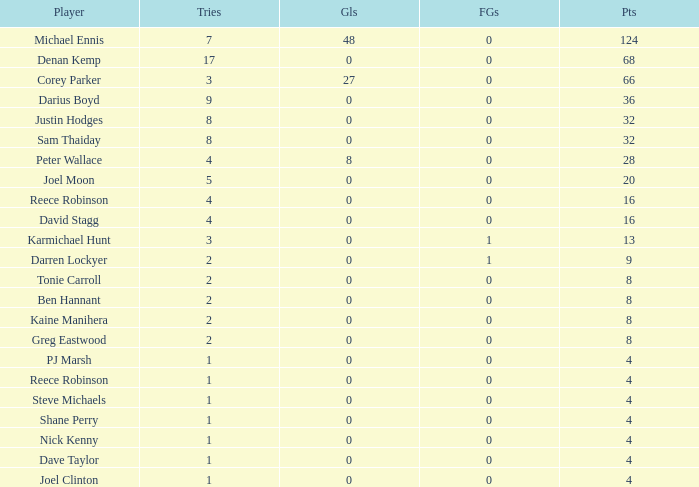How many goals did the player with less than 4 points have? 0.0. 